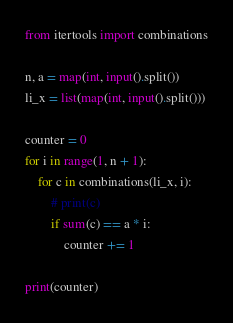Convert code to text. <code><loc_0><loc_0><loc_500><loc_500><_Python_>from itertools import combinations

n, a = map(int, input().split())
li_x = list(map(int, input().split()))

counter = 0
for i in range(1, n + 1):
    for c in combinations(li_x, i):
        # print(c)
        if sum(c) == a * i:
            counter += 1

print(counter)</code> 